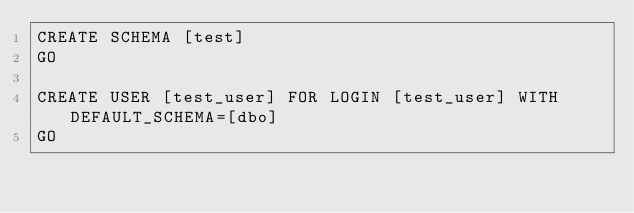<code> <loc_0><loc_0><loc_500><loc_500><_SQL_>CREATE SCHEMA [test]
GO

CREATE USER [test_user] FOR LOGIN [test_user] WITH DEFAULT_SCHEMA=[dbo]
GO</code> 